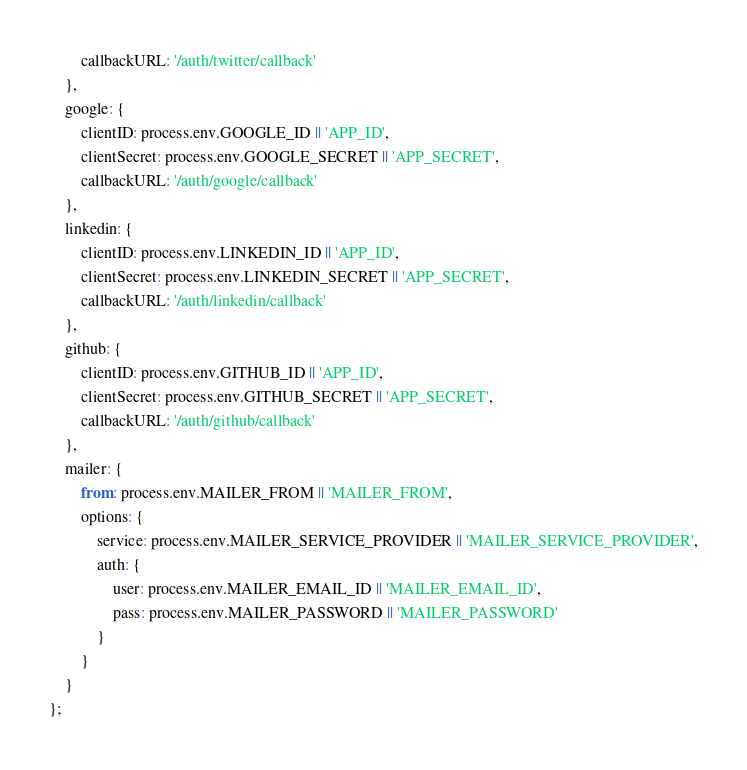<code> <loc_0><loc_0><loc_500><loc_500><_JavaScript_>		callbackURL: '/auth/twitter/callback'
	},
	google: {
		clientID: process.env.GOOGLE_ID || 'APP_ID',
		clientSecret: process.env.GOOGLE_SECRET || 'APP_SECRET',
		callbackURL: '/auth/google/callback'
	},
	linkedin: {
		clientID: process.env.LINKEDIN_ID || 'APP_ID',
		clientSecret: process.env.LINKEDIN_SECRET || 'APP_SECRET',
		callbackURL: '/auth/linkedin/callback'
	},
	github: {
		clientID: process.env.GITHUB_ID || 'APP_ID',
		clientSecret: process.env.GITHUB_SECRET || 'APP_SECRET',
		callbackURL: '/auth/github/callback'
	},
	mailer: {
		from: process.env.MAILER_FROM || 'MAILER_FROM',
		options: {
			service: process.env.MAILER_SERVICE_PROVIDER || 'MAILER_SERVICE_PROVIDER',
			auth: {
				user: process.env.MAILER_EMAIL_ID || 'MAILER_EMAIL_ID',
				pass: process.env.MAILER_PASSWORD || 'MAILER_PASSWORD'
			}
		}
	}
};
</code> 